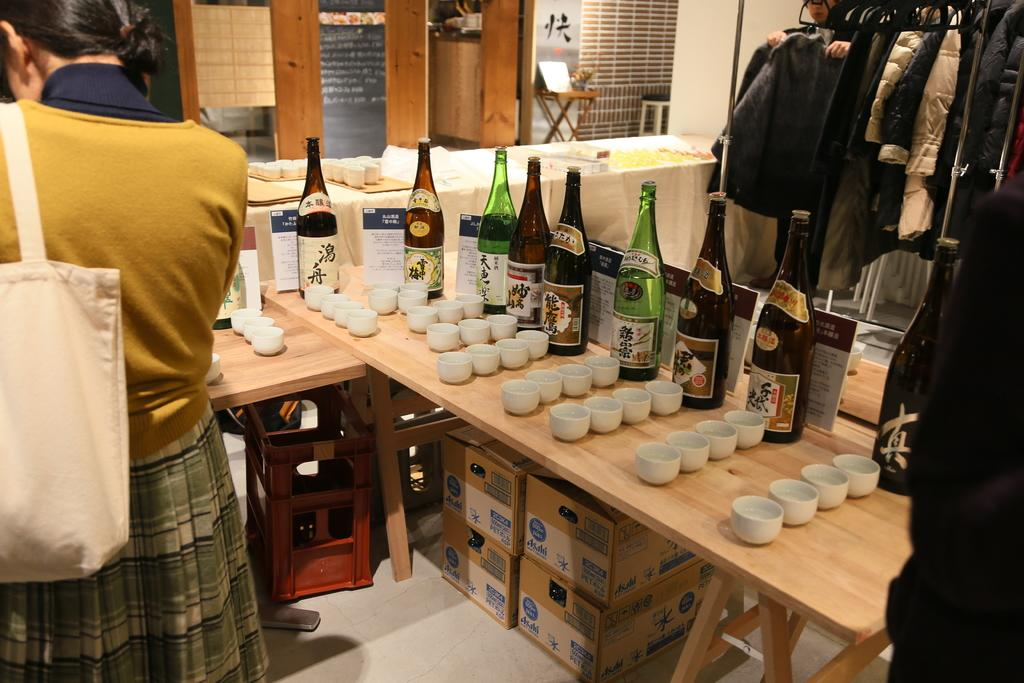Who is present in the image? There is a woman in the image. What is the woman carrying? The woman is carrying a bag. What objects can be seen on the table? There are bottles and cups on the table. What is stored under the table? There are boxes under the table. What type of items are visible in the image related to clothing? Clothes are visible in the image. What type of cakes is the lawyer eating in the image? There is no lawyer or cakes present in the image. How many yams are visible in the image? There are no yams visible in the image. 